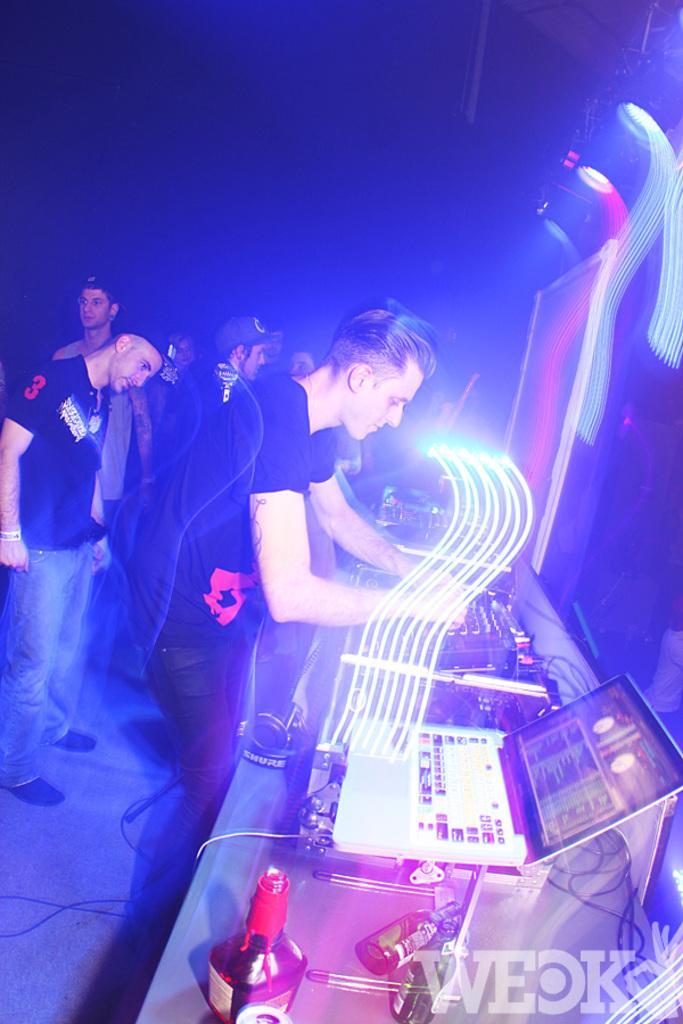In one or two sentences, can you explain what this image depicts? In this picture we can see a group of people standing and in front of them we can see a laptop, bottles, machine and in the background it is dark. 